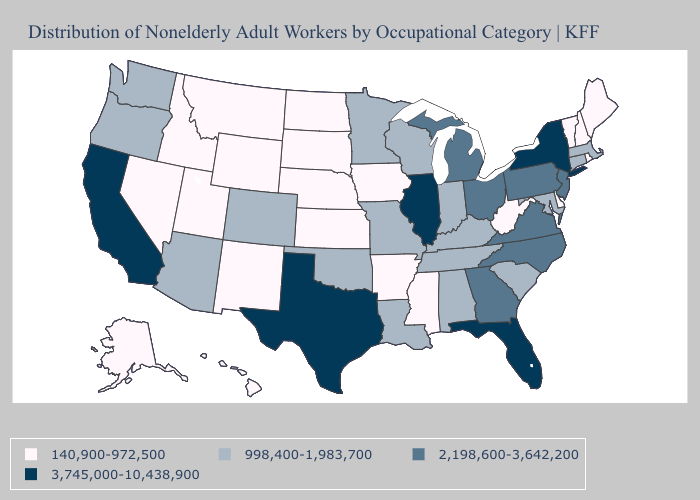What is the value of Louisiana?
Write a very short answer. 998,400-1,983,700. Which states have the lowest value in the Northeast?
Be succinct. Maine, New Hampshire, Rhode Island, Vermont. Name the states that have a value in the range 140,900-972,500?
Quick response, please. Alaska, Arkansas, Delaware, Hawaii, Idaho, Iowa, Kansas, Maine, Mississippi, Montana, Nebraska, Nevada, New Hampshire, New Mexico, North Dakota, Rhode Island, South Dakota, Utah, Vermont, West Virginia, Wyoming. What is the value of Wisconsin?
Short answer required. 998,400-1,983,700. Which states have the lowest value in the USA?
Write a very short answer. Alaska, Arkansas, Delaware, Hawaii, Idaho, Iowa, Kansas, Maine, Mississippi, Montana, Nebraska, Nevada, New Hampshire, New Mexico, North Dakota, Rhode Island, South Dakota, Utah, Vermont, West Virginia, Wyoming. Among the states that border Texas , does Arkansas have the highest value?
Quick response, please. No. What is the value of Missouri?
Write a very short answer. 998,400-1,983,700. What is the highest value in the USA?
Answer briefly. 3,745,000-10,438,900. How many symbols are there in the legend?
Concise answer only. 4. Does Colorado have the same value as Louisiana?
Keep it brief. Yes. Does Connecticut have the lowest value in the USA?
Keep it brief. No. Does the map have missing data?
Answer briefly. No. Is the legend a continuous bar?
Write a very short answer. No. Does Alaska have a higher value than Tennessee?
Concise answer only. No. What is the value of New York?
Keep it brief. 3,745,000-10,438,900. 